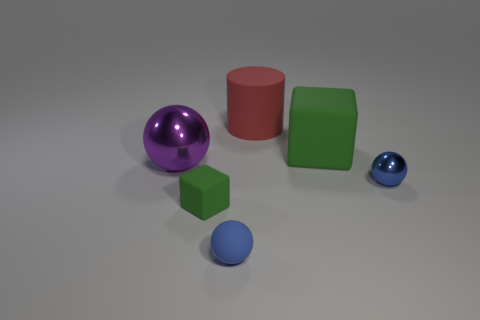What is the color of the matte sphere?
Offer a very short reply. Blue. There is a green block that is on the right side of the big red cylinder; what material is it?
Give a very brief answer. Rubber. Is the number of big rubber objects that are right of the big green rubber thing the same as the number of large purple shiny things?
Offer a very short reply. No. Is the shape of the big red object the same as the purple object?
Offer a very short reply. No. Are there any other things of the same color as the tiny shiny thing?
Give a very brief answer. Yes. The rubber thing that is both to the left of the big red cylinder and to the right of the small green rubber cube has what shape?
Offer a terse response. Sphere. Are there the same number of red cylinders that are in front of the small rubber cube and big cylinders right of the big green thing?
Your answer should be very brief. Yes. How many cylinders are either blue things or big purple shiny things?
Keep it short and to the point. 0. What number of small blue objects are the same material as the large ball?
Offer a terse response. 1. There is a thing that is the same color as the large cube; what is its shape?
Make the answer very short. Cube. 